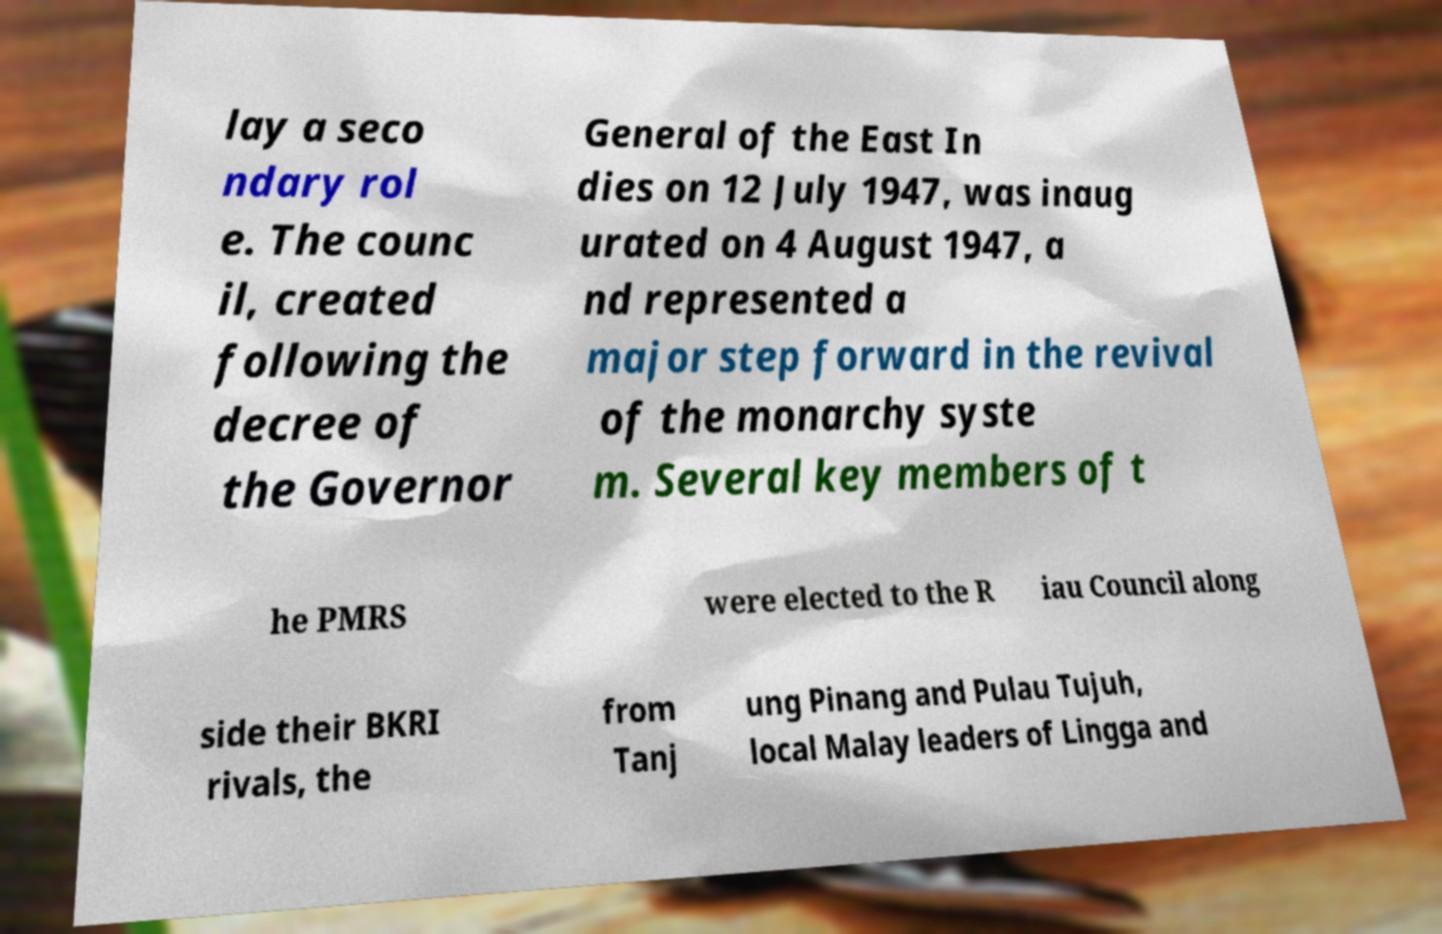Can you accurately transcribe the text from the provided image for me? lay a seco ndary rol e. The counc il, created following the decree of the Governor General of the East In dies on 12 July 1947, was inaug urated on 4 August 1947, a nd represented a major step forward in the revival of the monarchy syste m. Several key members of t he PMRS were elected to the R iau Council along side their BKRI rivals, the from Tanj ung Pinang and Pulau Tujuh, local Malay leaders of Lingga and 